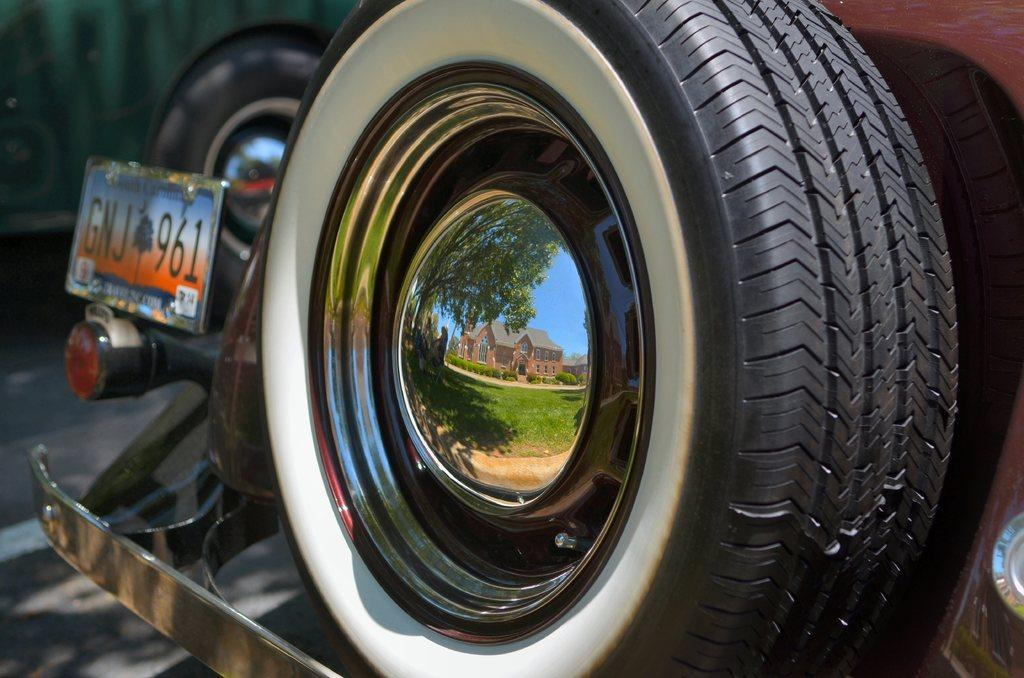What is the main subject of the image? The main subject of the image is a vehicle. What part of the vehicle is mentioned in the facts? The vehicle has a tyre attached to it. What detail can be observed about the tyre? The tyre has a reflection of a home on the alloy wheel. Who is the owner of the vehicle in the image? The facts provided do not mention the owner of the vehicle, so it cannot be determined from the image. 